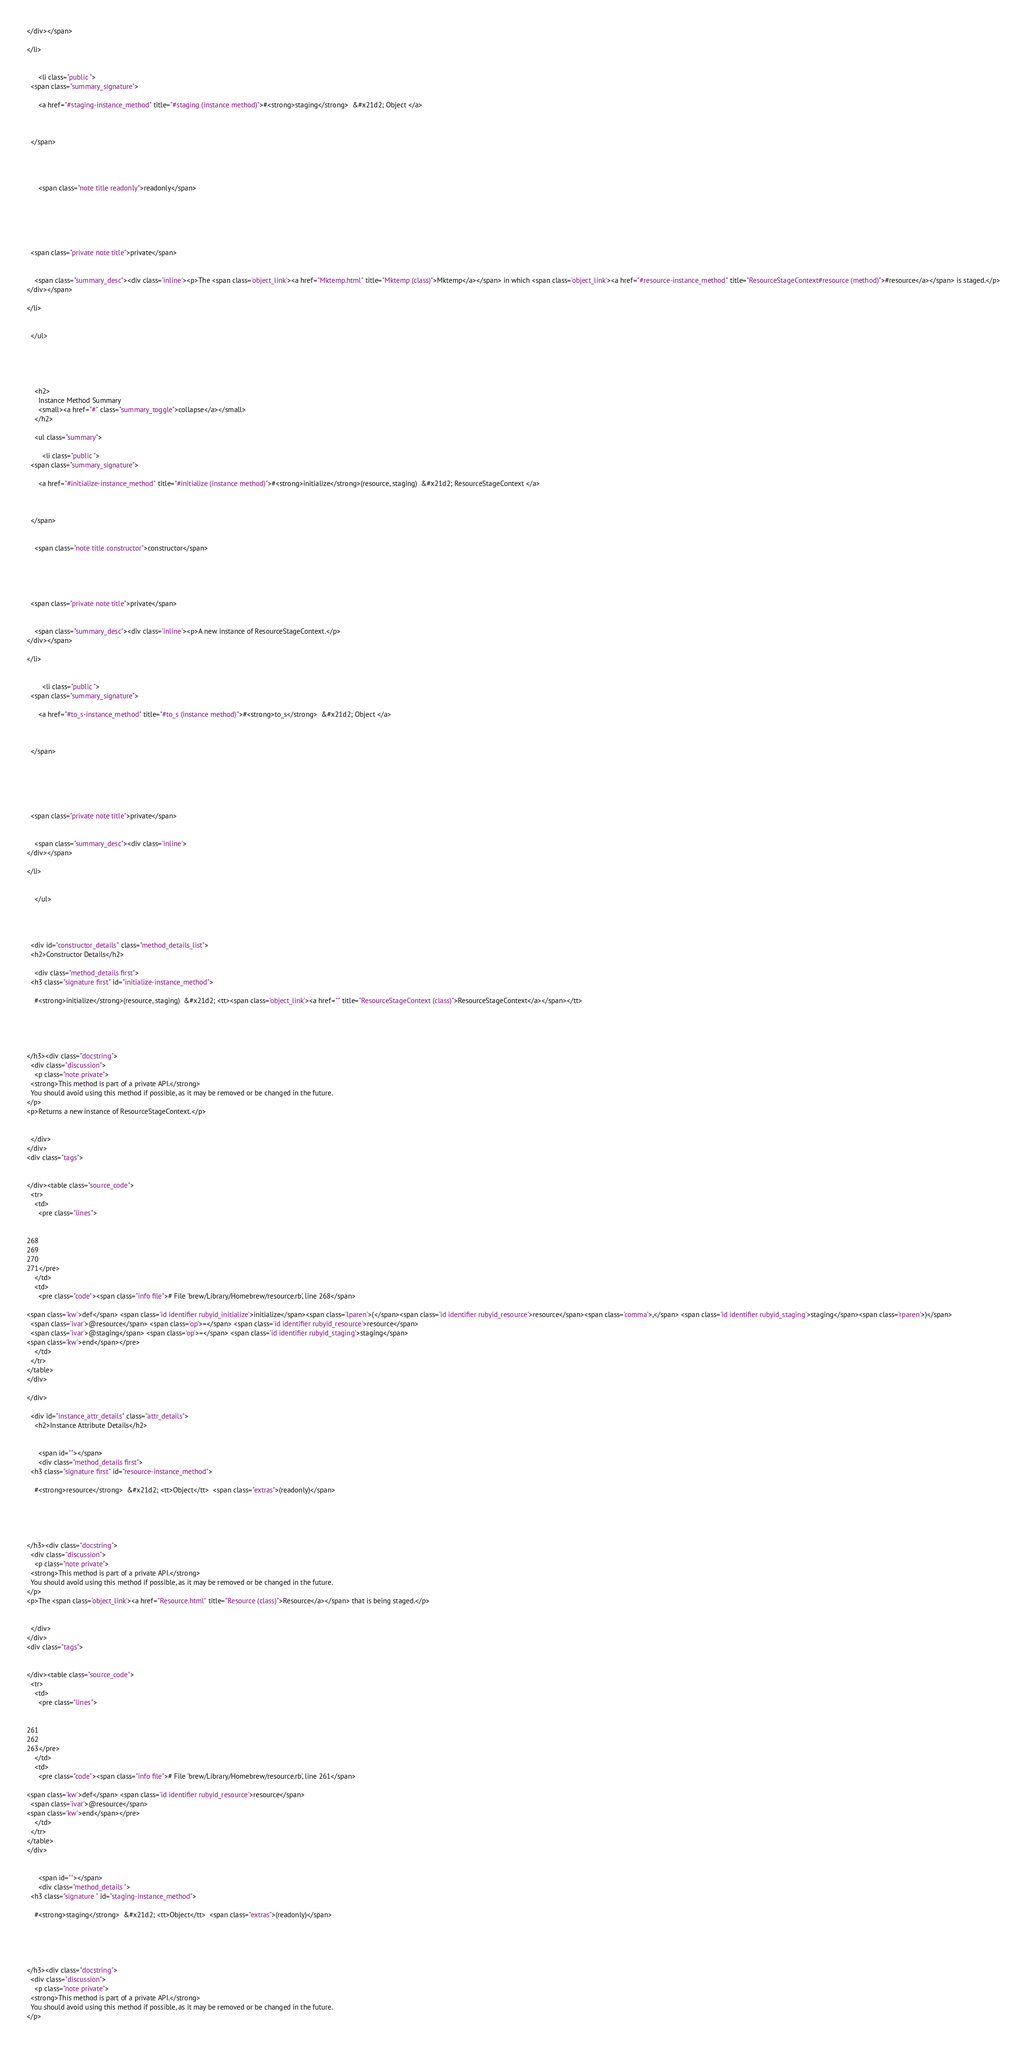Convert code to text. <code><loc_0><loc_0><loc_500><loc_500><_HTML_></div></span>
  
</li>

    
      <li class="public ">
  <span class="summary_signature">
    
      <a href="#staging-instance_method" title="#staging (instance method)">#<strong>staging</strong>  &#x21d2; Object </a>
    

    
  </span>
  
  
  
    
      <span class="note title readonly">readonly</span>
    
    
  
  
  
  
  <span class="private note title">private</span>

  
    <span class="summary_desc"><div class='inline'><p>The <span class='object_link'><a href="Mktemp.html" title="Mktemp (class)">Mktemp</a></span> in which <span class='object_link'><a href="#resource-instance_method" title="ResourceStageContext#resource (method)">#resource</a></span> is staged.</p>
</div></span>
  
</li>

    
  </ul>




  
    <h2>
      Instance Method Summary
      <small><a href="#" class="summary_toggle">collapse</a></small>
    </h2>

    <ul class="summary">
      
        <li class="public ">
  <span class="summary_signature">
    
      <a href="#initialize-instance_method" title="#initialize (instance method)">#<strong>initialize</strong>(resource, staging)  &#x21d2; ResourceStageContext </a>
    

    
  </span>
  
  
    <span class="note title constructor">constructor</span>
  
  
  
  
  
  <span class="private note title">private</span>

  
    <span class="summary_desc"><div class='inline'><p>A new instance of ResourceStageContext.</p>
</div></span>
  
</li>

      
        <li class="public ">
  <span class="summary_signature">
    
      <a href="#to_s-instance_method" title="#to_s (instance method)">#<strong>to_s</strong>  &#x21d2; Object </a>
    

    
  </span>
  
  
  
  
  
  
  <span class="private note title">private</span>

  
    <span class="summary_desc"><div class='inline'>
</div></span>
  
</li>

      
    </ul>
  


  
  <div id="constructor_details" class="method_details_list">
  <h2>Constructor Details</h2>
  
    <div class="method_details first">
  <h3 class="signature first" id="initialize-instance_method">
  
    #<strong>initialize</strong>(resource, staging)  &#x21d2; <tt><span class='object_link'><a href="" title="ResourceStageContext (class)">ResourceStageContext</a></span></tt> 
  

  

  
</h3><div class="docstring">
  <div class="discussion">
    <p class="note private">
  <strong>This method is part of a private API.</strong>
  You should avoid using this method if possible, as it may be removed or be changed in the future.
</p>
<p>Returns a new instance of ResourceStageContext.</p>


  </div>
</div>
<div class="tags">
  

</div><table class="source_code">
  <tr>
    <td>
      <pre class="lines">


268
269
270
271</pre>
    </td>
    <td>
      <pre class="code"><span class="info file"># File 'brew/Library/Homebrew/resource.rb', line 268</span>

<span class='kw'>def</span> <span class='id identifier rubyid_initialize'>initialize</span><span class='lparen'>(</span><span class='id identifier rubyid_resource'>resource</span><span class='comma'>,</span> <span class='id identifier rubyid_staging'>staging</span><span class='rparen'>)</span>
  <span class='ivar'>@resource</span> <span class='op'>=</span> <span class='id identifier rubyid_resource'>resource</span>
  <span class='ivar'>@staging</span> <span class='op'>=</span> <span class='id identifier rubyid_staging'>staging</span>
<span class='kw'>end</span></pre>
    </td>
  </tr>
</table>
</div>
  
</div>

  <div id="instance_attr_details" class="attr_details">
    <h2>Instance Attribute Details</h2>
    
      
      <span id=""></span>
      <div class="method_details first">
  <h3 class="signature first" id="resource-instance_method">
  
    #<strong>resource</strong>  &#x21d2; <tt>Object</tt>  <span class="extras">(readonly)</span>
  

  

  
</h3><div class="docstring">
  <div class="discussion">
    <p class="note private">
  <strong>This method is part of a private API.</strong>
  You should avoid using this method if possible, as it may be removed or be changed in the future.
</p>
<p>The <span class='object_link'><a href="Resource.html" title="Resource (class)">Resource</a></span> that is being staged.</p>


  </div>
</div>
<div class="tags">
  

</div><table class="source_code">
  <tr>
    <td>
      <pre class="lines">


261
262
263</pre>
    </td>
    <td>
      <pre class="code"><span class="info file"># File 'brew/Library/Homebrew/resource.rb', line 261</span>

<span class='kw'>def</span> <span class='id identifier rubyid_resource'>resource</span>
  <span class='ivar'>@resource</span>
<span class='kw'>end</span></pre>
    </td>
  </tr>
</table>
</div>
    
      
      <span id=""></span>
      <div class="method_details ">
  <h3 class="signature " id="staging-instance_method">
  
    #<strong>staging</strong>  &#x21d2; <tt>Object</tt>  <span class="extras">(readonly)</span>
  

  

  
</h3><div class="docstring">
  <div class="discussion">
    <p class="note private">
  <strong>This method is part of a private API.</strong>
  You should avoid using this method if possible, as it may be removed or be changed in the future.
</p></code> 